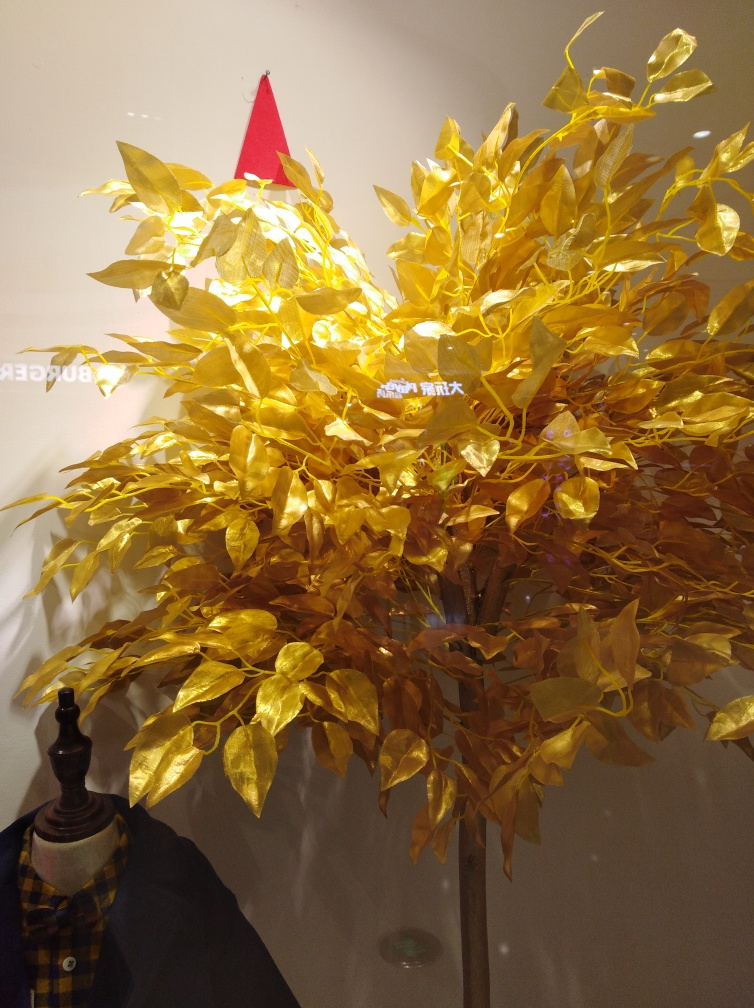Is the subject well-defined? The subject, which appears to be a tree adorned with golden leaves, is strikingly well-defined against a plain background. The golden color gives it a vivid and enchanting quality, which is further amplified by the lighting that seems to accentuate its sheen. 